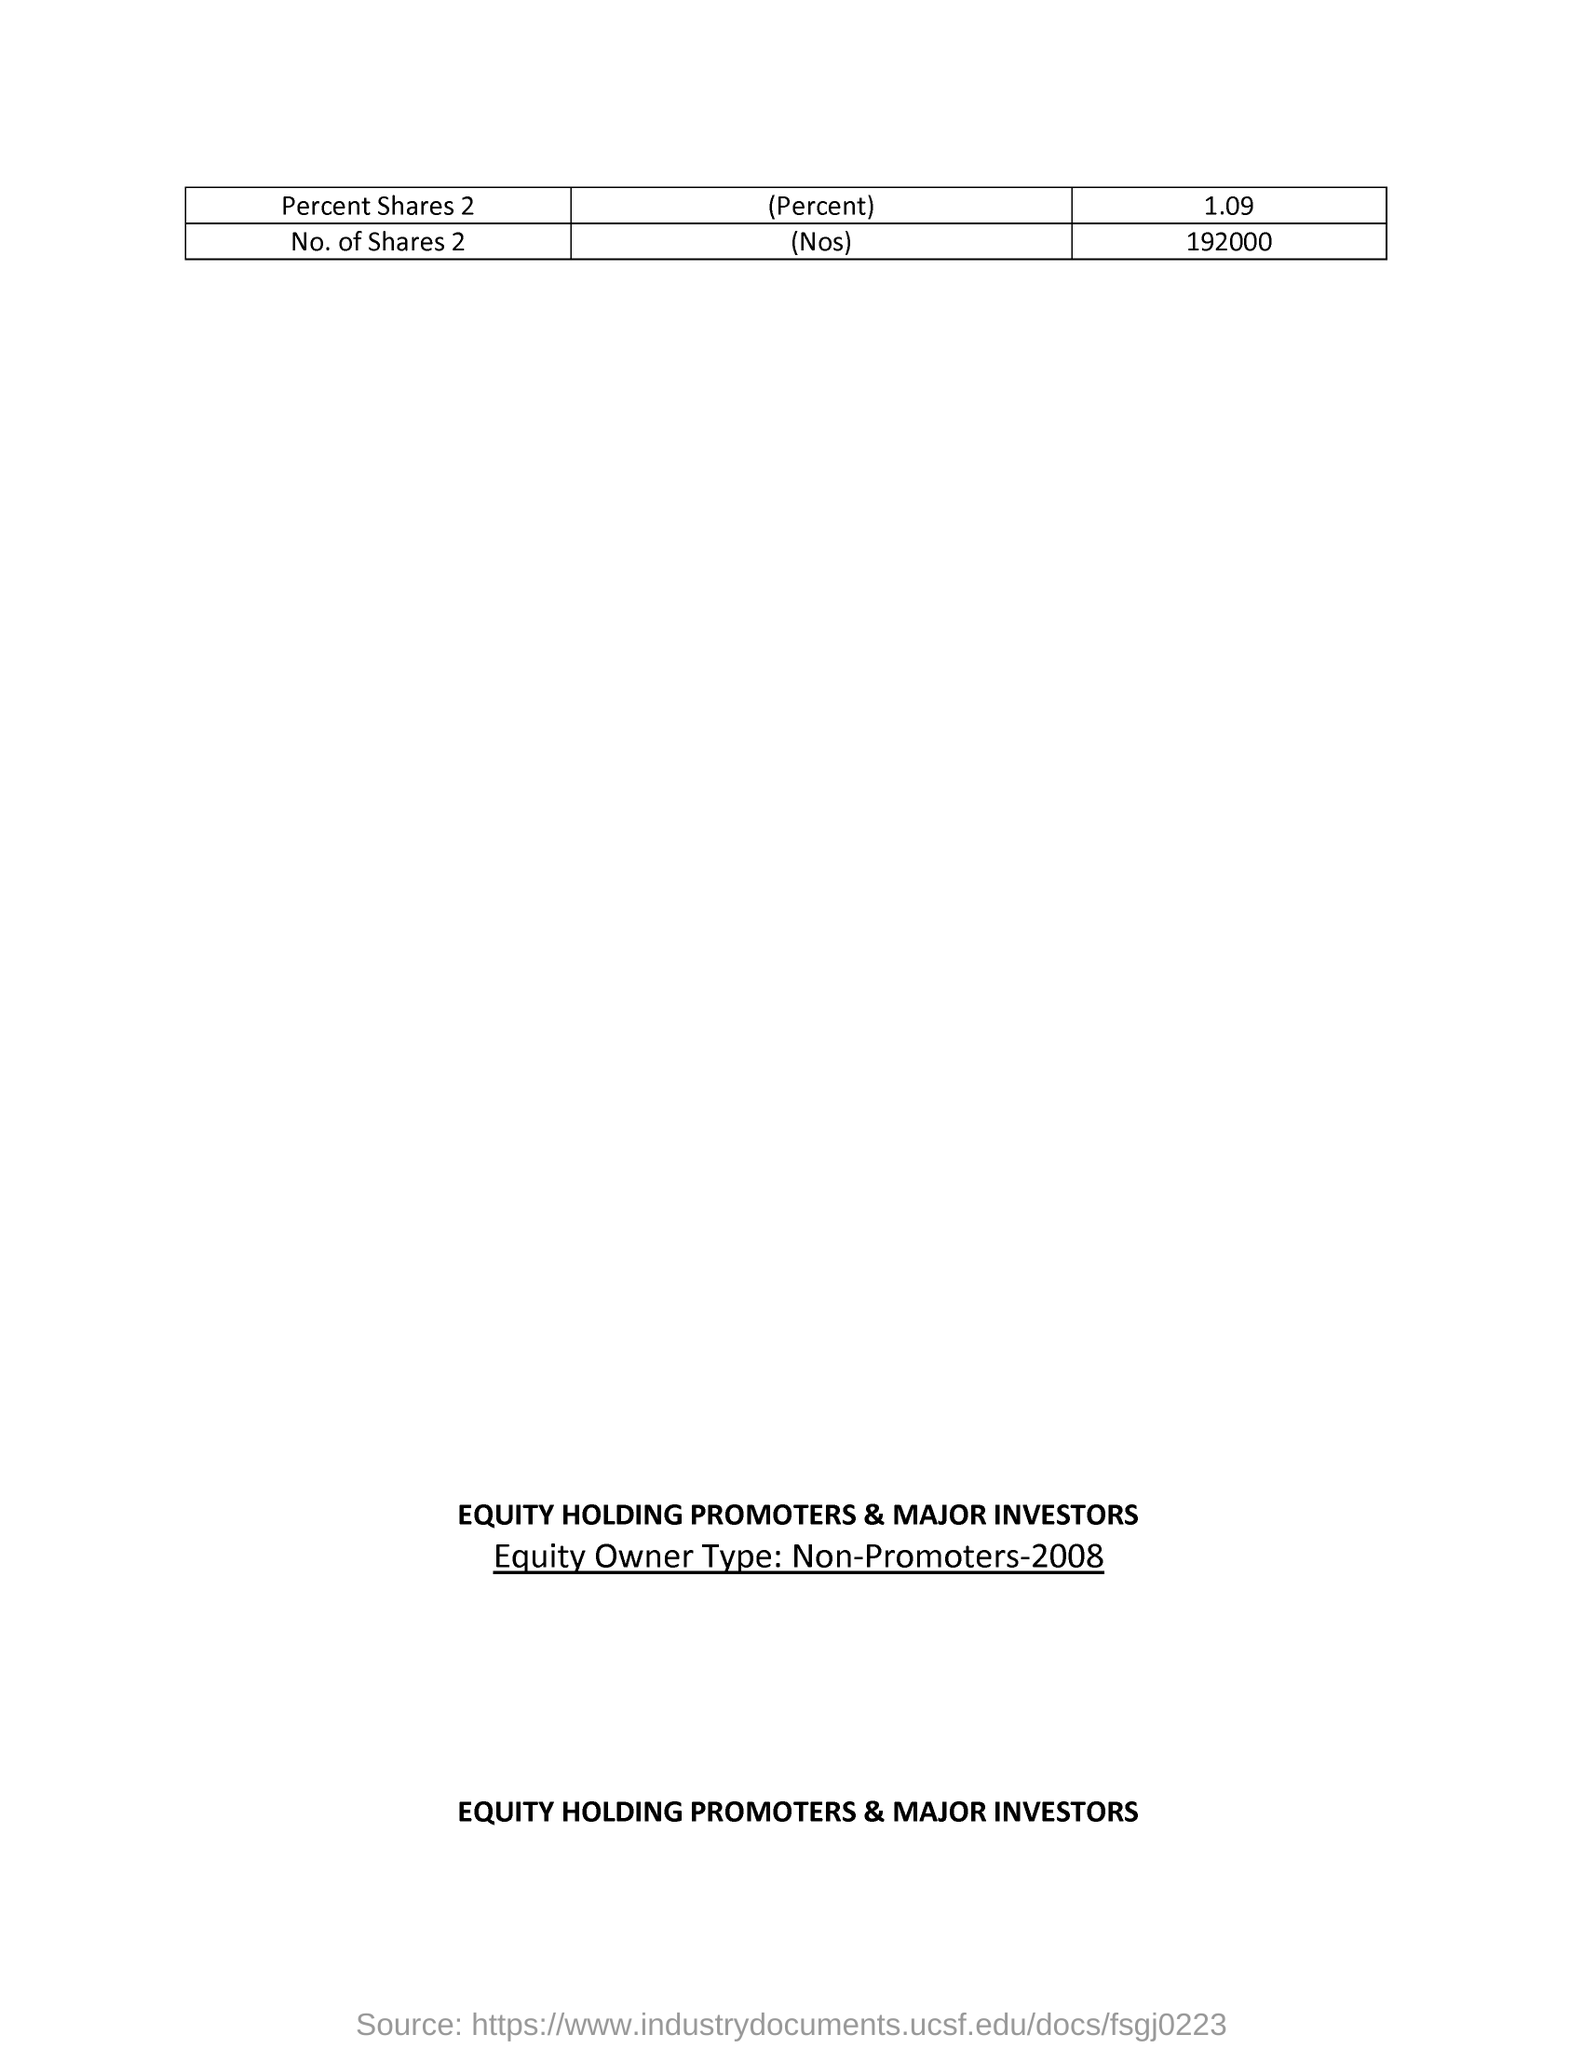What is the equity owner type?
Offer a terse response. Non-Promoters-2008. 